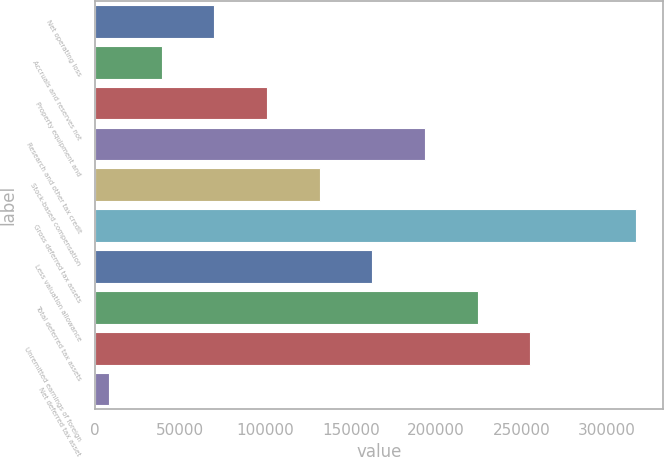Convert chart. <chart><loc_0><loc_0><loc_500><loc_500><bar_chart><fcel>Net operating loss<fcel>Accruals and reserves not<fcel>Property equipment and<fcel>Research and other tax credit<fcel>Stock-based compensation<fcel>Gross deferred tax assets<fcel>Less valuation allowance<fcel>Total deferred tax assets<fcel>Unremitted earnings of foreign<fcel>Net deferred tax asset<nl><fcel>69979.6<fcel>39102.8<fcel>100856<fcel>193528<fcel>131733<fcel>316994<fcel>162610<fcel>224405<fcel>255282<fcel>8226<nl></chart> 